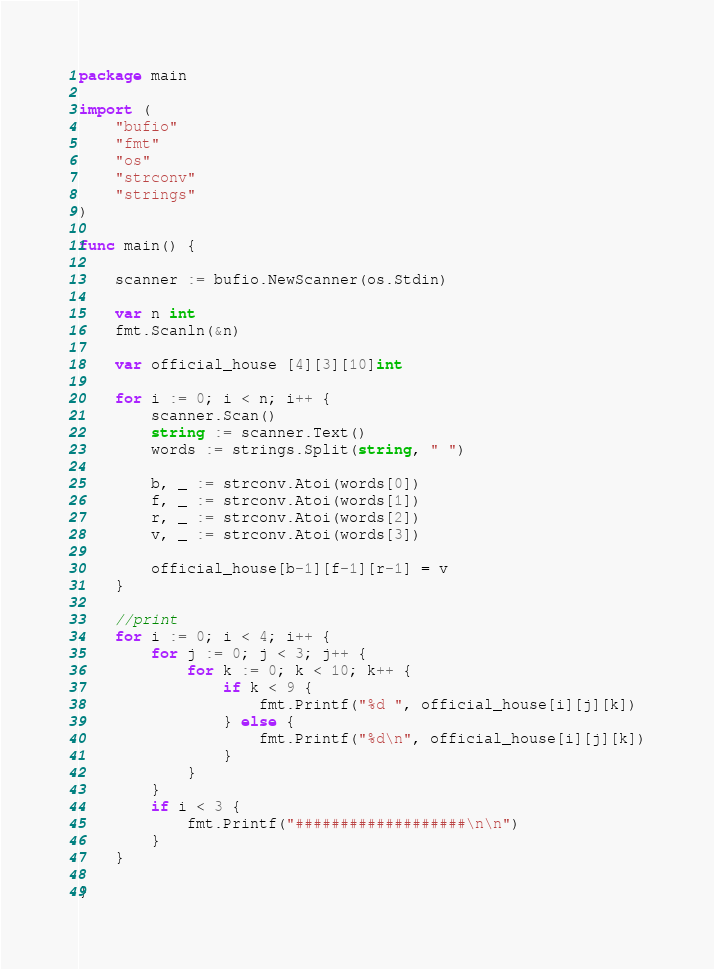<code> <loc_0><loc_0><loc_500><loc_500><_Go_>package main

import (
	"bufio"
	"fmt"
	"os"
	"strconv"
	"strings"
)

func main() {

	scanner := bufio.NewScanner(os.Stdin)

	var n int
	fmt.Scanln(&n)

	var official_house [4][3][10]int

	for i := 0; i < n; i++ {
		scanner.Scan()
		string := scanner.Text()
		words := strings.Split(string, " ")

		b, _ := strconv.Atoi(words[0])
		f, _ := strconv.Atoi(words[1])
		r, _ := strconv.Atoi(words[2])
		v, _ := strconv.Atoi(words[3])

		official_house[b-1][f-1][r-1] = v
	}

	//print
	for i := 0; i < 4; i++ {
		for j := 0; j < 3; j++ {
			for k := 0; k < 10; k++ {
				if k < 9 {
					fmt.Printf("%d ", official_house[i][j][k])
				} else {
					fmt.Printf("%d\n", official_house[i][j][k])
				}
			}
		}
		if i < 3 {
			fmt.Printf("###################\n\n")
		}
	}

}

</code> 